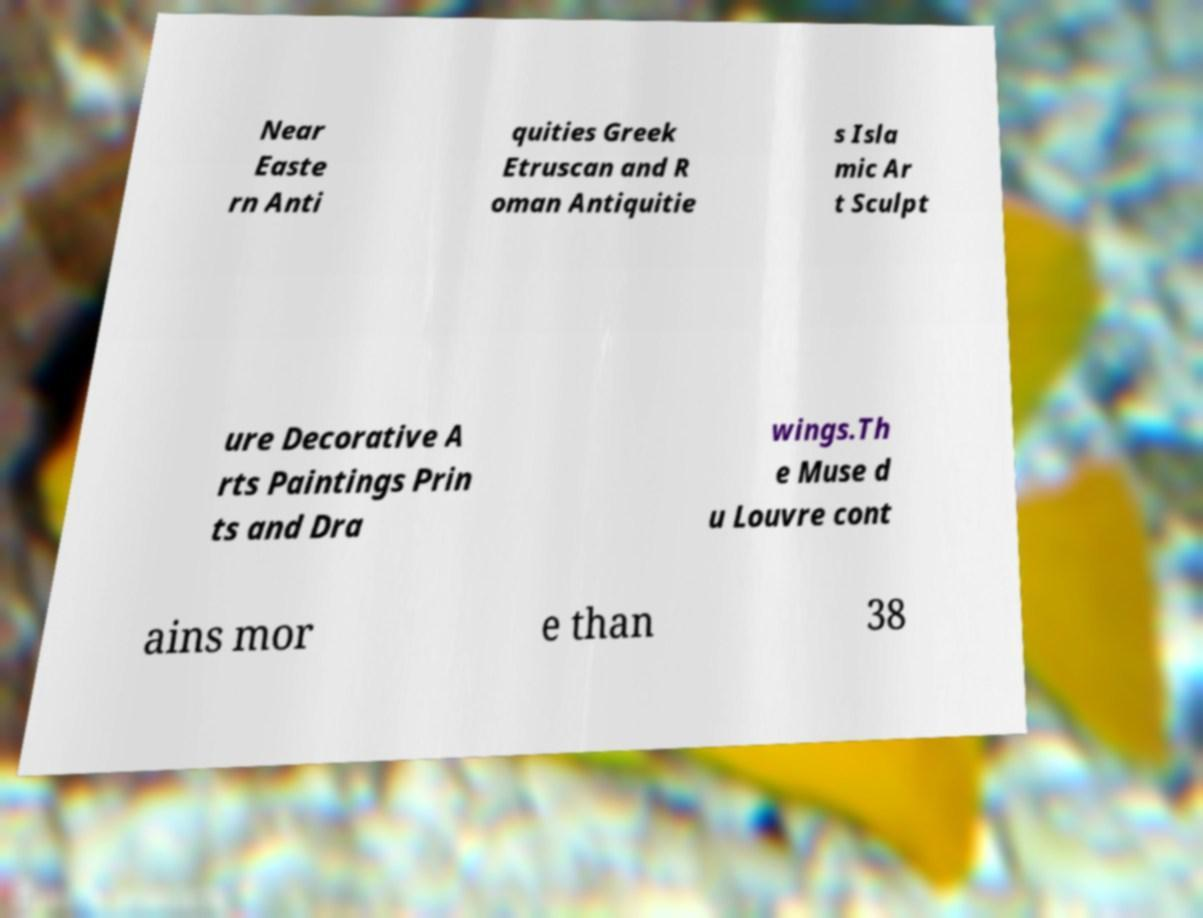Please identify and transcribe the text found in this image. Near Easte rn Anti quities Greek Etruscan and R oman Antiquitie s Isla mic Ar t Sculpt ure Decorative A rts Paintings Prin ts and Dra wings.Th e Muse d u Louvre cont ains mor e than 38 